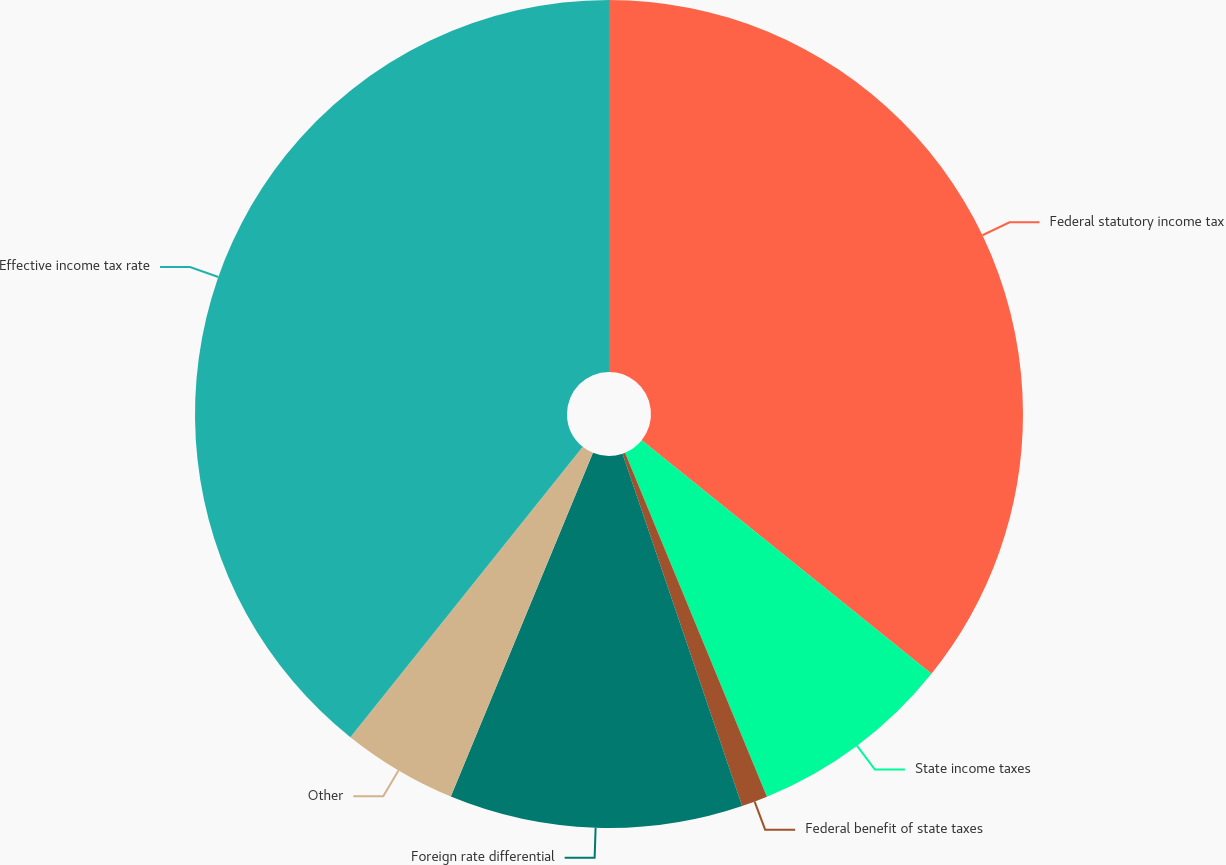<chart> <loc_0><loc_0><loc_500><loc_500><pie_chart><fcel>Federal statutory income tax<fcel>State income taxes<fcel>Federal benefit of state taxes<fcel>Foreign rate differential<fcel>Other<fcel>Effective income tax rate<nl><fcel>35.79%<fcel>7.98%<fcel>1.02%<fcel>11.45%<fcel>4.5%<fcel>39.26%<nl></chart> 